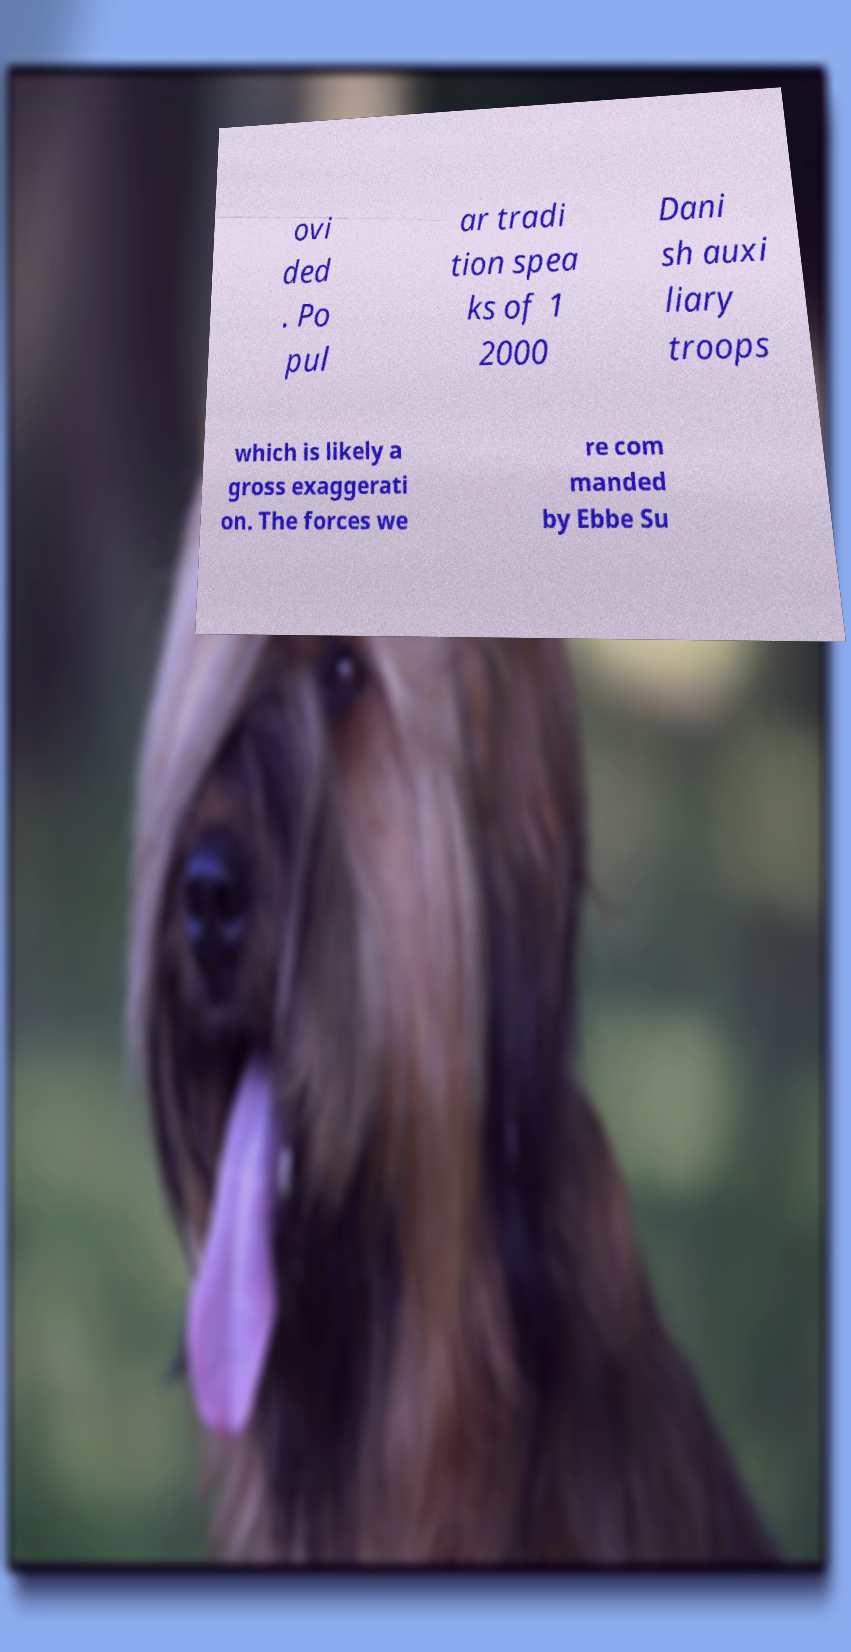There's text embedded in this image that I need extracted. Can you transcribe it verbatim? ovi ded . Po pul ar tradi tion spea ks of 1 2000 Dani sh auxi liary troops which is likely a gross exaggerati on. The forces we re com manded by Ebbe Su 